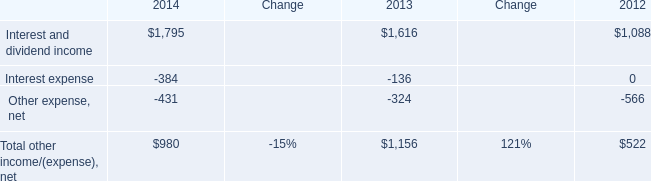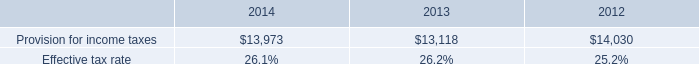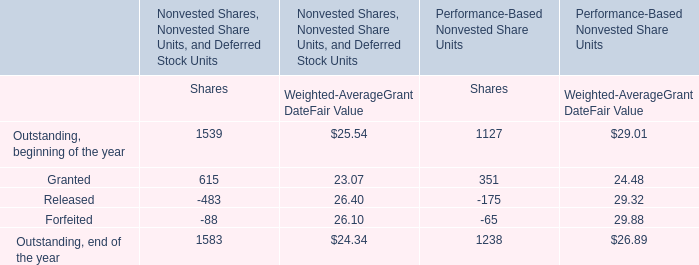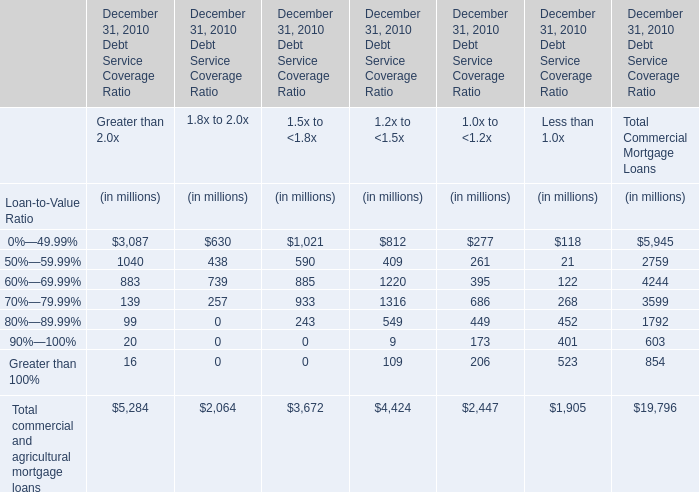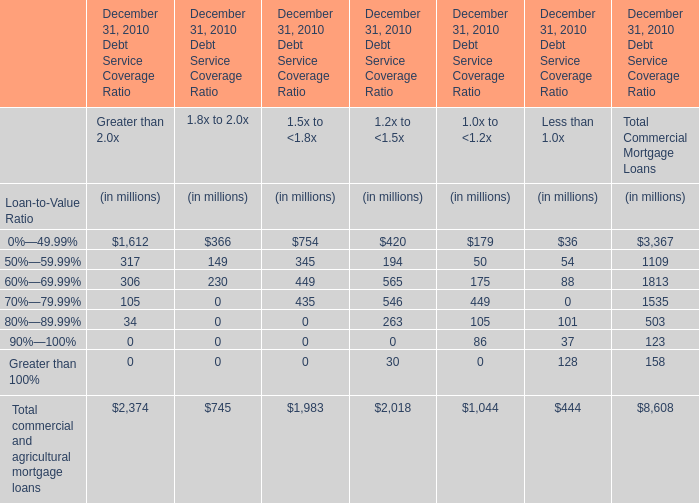what's the total amount of Provision for income taxes of 2014, and Interest and dividend income of 2012 ? 
Computations: (13973.0 + 1088.0)
Answer: 15061.0. 